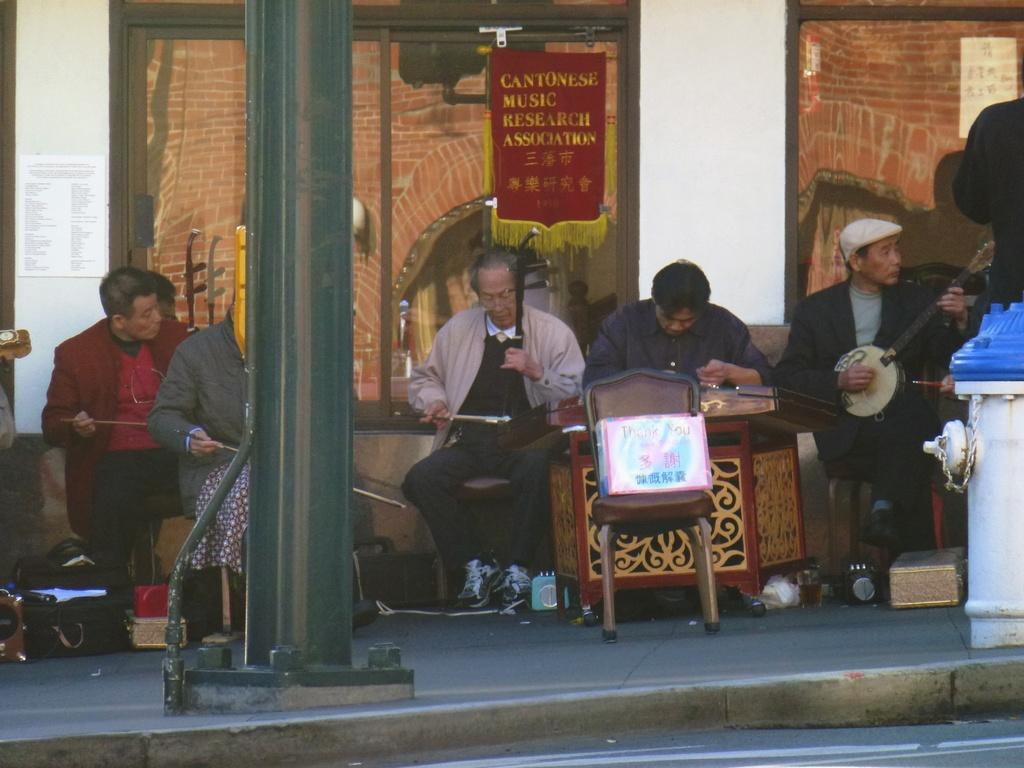What can be seen in the image involving multiple individuals? There are groups of people in the image. What is written or displayed at the top of the image? There is text at the top of the image. Where is a person located in the image, and what are they doing? There is a person sitting on the right side of the image, and they are holding an object. What type of ornament is the judge wearing in the image? There is no judge or ornament present in the image. What kind of test is being conducted in the image? There is no test being conducted in the image. 